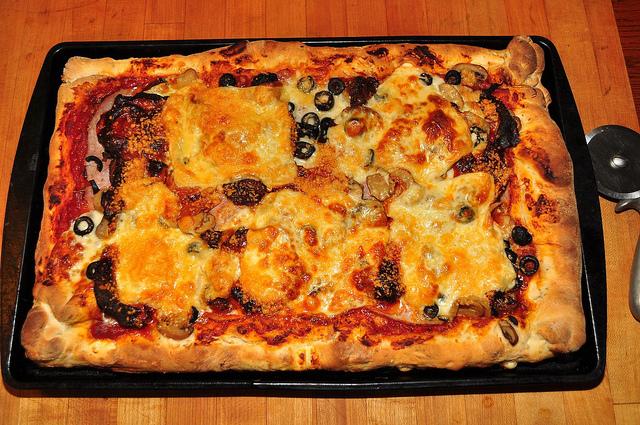Is this round?
Write a very short answer. No. What is the food on?
Keep it brief. Tray. What vegetable is on the pizza?
Keep it brief. Olives. 